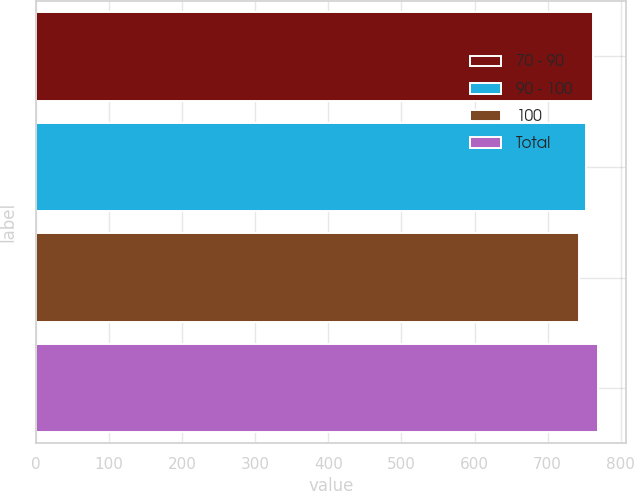<chart> <loc_0><loc_0><loc_500><loc_500><bar_chart><fcel>70 - 90<fcel>90 - 100<fcel>100<fcel>Total<nl><fcel>762<fcel>752<fcel>743<fcel>769<nl></chart> 